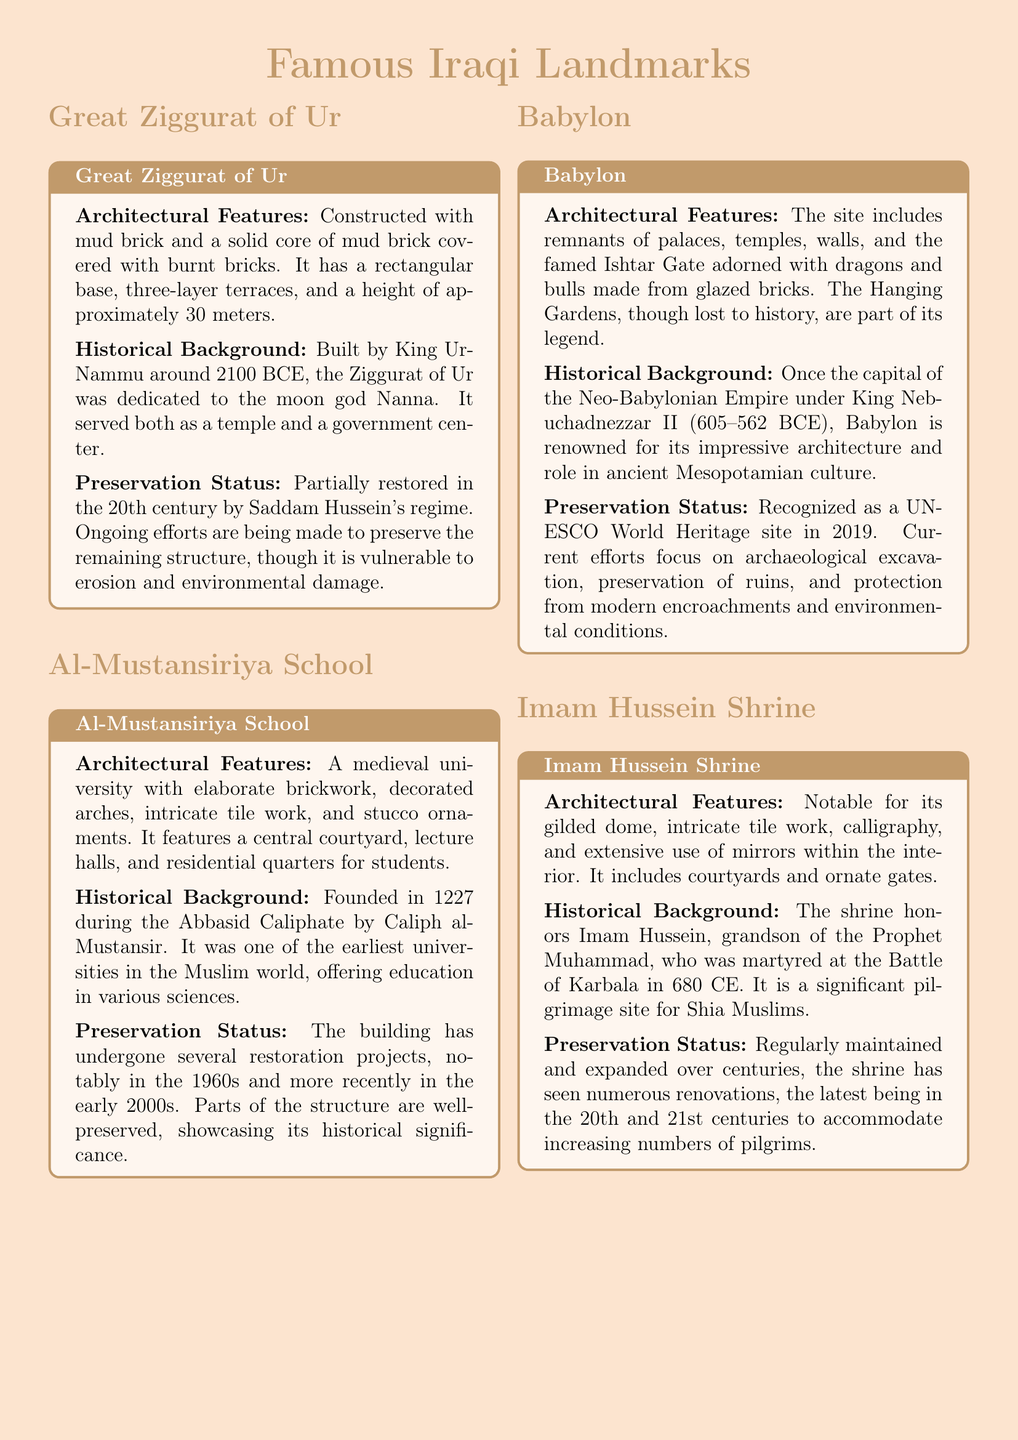What is the height of the Great Ziggurat of Ur? The height of the Great Ziggurat of Ur is approximately 30 meters.
Answer: 30 meters Who was the founder of Al-Mustansiriya School? Al-Mustansiriya School was founded by Caliph al-Mustansir.
Answer: Caliph al-Mustansir In what year was Babylon recognized as a UNESCO World Heritage site? Babylon was recognized as a UNESCO World Heritage site in 2019.
Answer: 2019 What major feature is found in the Imam Hussein Shrine? The Imam Hussein Shrine is notable for its gilded dome.
Answer: Gilded dome What type of materials were used to construct the Great Ziggurat of Ur? The Great Ziggurat of Ur was constructed with mud brick and burnt bricks.
Answer: Mud brick and burnt bricks Which historical figure was martyred at the Battle of Karbala? Imam Hussein, grandson of the Prophet Muhammad, was martyred at the Battle of Karbala.
Answer: Imam Hussein What is significant about Al-Mustansiriya School in the Muslim world? Al-Mustansiriya School was one of the earliest universities in the Muslim world.
Answer: Earliest universities What are the decorative features on the Ishtar Gate? The Ishtar Gate is adorned with dragons and bulls made from glazed bricks.
Answer: Dragons and bulls What is the preservation status of the Great Ziggurat of Ur? The Great Ziggurat of Ur has undergone partial restoration in the 20th century.
Answer: Partially restored 